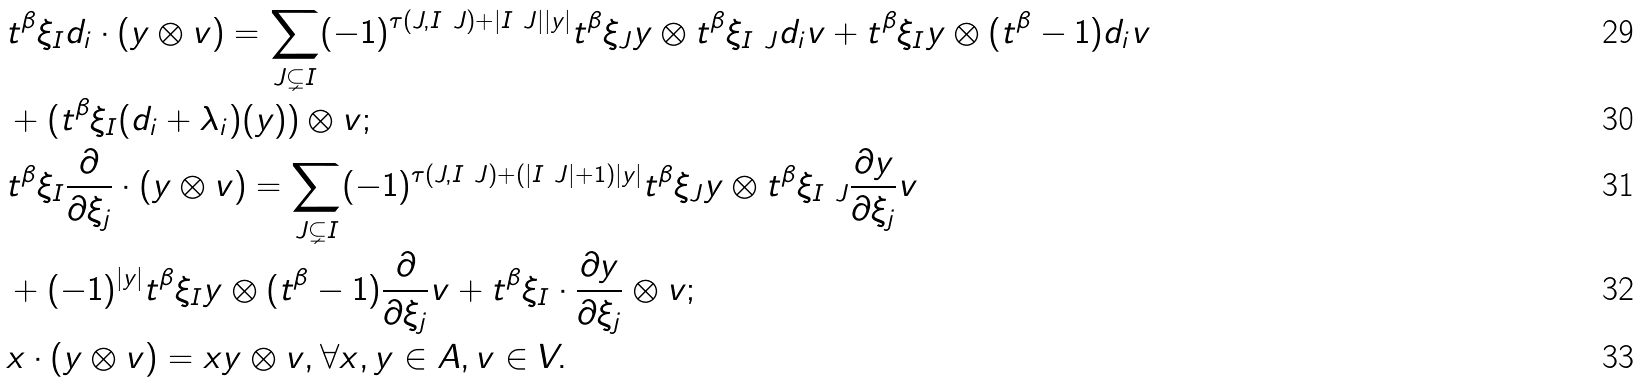Convert formula to latex. <formula><loc_0><loc_0><loc_500><loc_500>& t ^ { \beta } \xi _ { I } d _ { i } \cdot ( y \otimes v ) = \sum _ { J \subsetneq I } ( - 1 ) ^ { \tau ( J , I \ J ) + | I \ J | | y | } t ^ { \beta } \xi _ { J } y \otimes t ^ { \beta } \xi _ { I \ J } d _ { i } v + t ^ { \beta } \xi _ { I } y \otimes ( t ^ { \beta } - 1 ) d _ { i } v \\ & + ( t ^ { \beta } \xi _ { I } ( d _ { i } + \lambda _ { i } ) ( y ) ) \otimes v ; \\ & t ^ { \beta } \xi _ { I } \frac { \partial } { \partial \xi _ { j } } \cdot ( y \otimes v ) = \sum _ { J \subsetneq I } ( - 1 ) ^ { \tau ( J , I \ J ) + ( | I \ J | + 1 ) | y | } t ^ { \beta } \xi _ { J } y \otimes t ^ { \beta } \xi _ { I \ J } \frac { \partial y } { \partial \xi _ { j } } v \\ & + ( - 1 ) ^ { | y | } t ^ { \beta } \xi _ { I } y \otimes ( t ^ { \beta } - 1 ) \frac { \partial } { \partial \xi _ { j } } v + t ^ { \beta } \xi _ { I } \cdot \frac { \partial y } { \partial \xi _ { j } } \otimes v ; \\ & x \cdot ( y \otimes v ) = x y \otimes v , \forall x , y \in A , v \in V .</formula> 